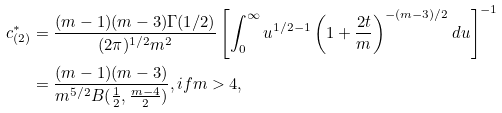Convert formula to latex. <formula><loc_0><loc_0><loc_500><loc_500>c _ { ( 2 ) } ^ { \ast } & = \frac { ( m - 1 ) ( m - 3 ) \Gamma ( 1 / 2 ) } { ( 2 \pi ) ^ { 1 / 2 } m ^ { 2 } } \left [ \int _ { 0 } ^ { \infty } u ^ { 1 / 2 - 1 } \left ( 1 + \frac { 2 t } { m } \right ) ^ { - ( m - 3 ) / 2 } d u \right ] ^ { - 1 } \\ & = \frac { ( m - 1 ) ( m - 3 ) } { m ^ { 5 / 2 } B ( \frac { 1 } { 2 } , \frac { m - 4 } { 2 } ) } , i f m > 4 ,</formula> 